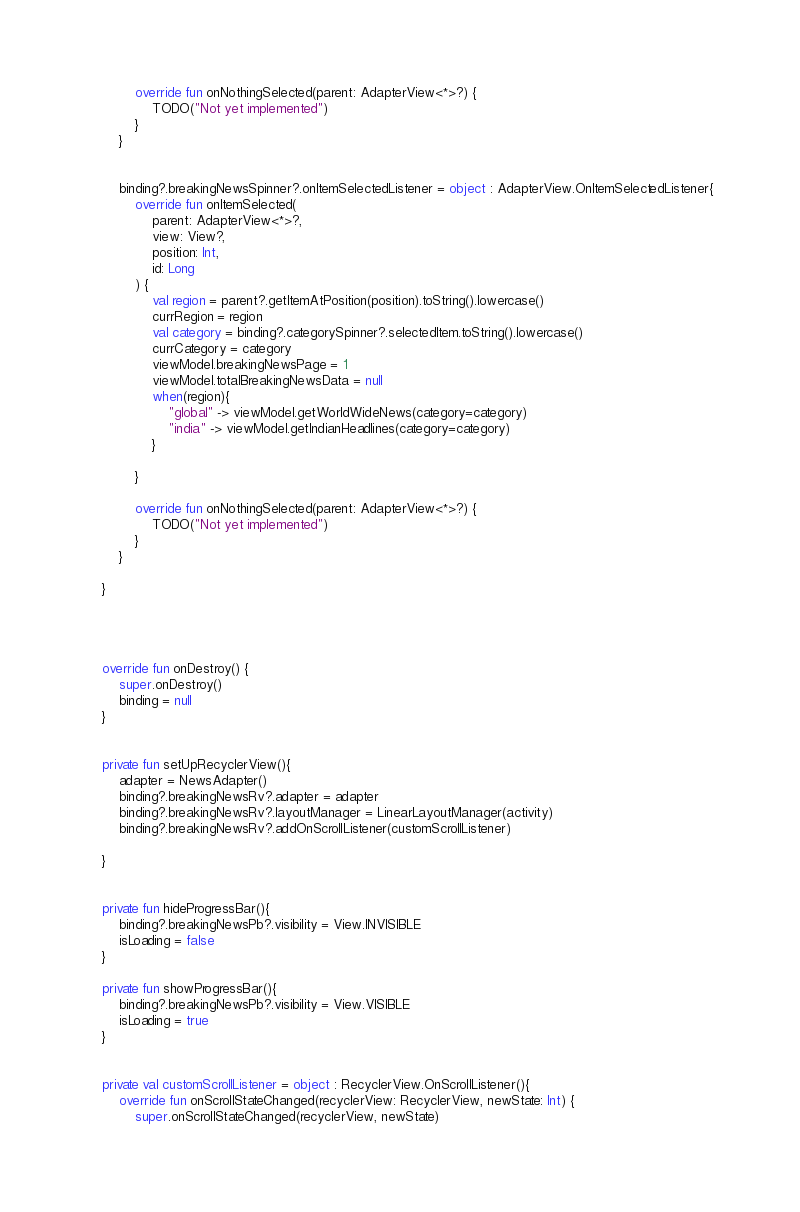Convert code to text. <code><loc_0><loc_0><loc_500><loc_500><_Kotlin_>            override fun onNothingSelected(parent: AdapterView<*>?) {
                TODO("Not yet implemented")
            }
        }


        binding?.breakingNewsSpinner?.onItemSelectedListener = object : AdapterView.OnItemSelectedListener{
            override fun onItemSelected(
                parent: AdapterView<*>?,
                view: View?,
                position: Int,
                id: Long
            ) {
                val region = parent?.getItemAtPosition(position).toString().lowercase()
                currRegion = region
                val category = binding?.categorySpinner?.selectedItem.toString().lowercase()
                currCategory = category
                viewModel.breakingNewsPage = 1
                viewModel.totalBreakingNewsData = null
                when(region){
                    "global" -> viewModel.getWorldWideNews(category=category)
                    "india" -> viewModel.getIndianHeadlines(category=category)
                }

            }

            override fun onNothingSelected(parent: AdapterView<*>?) {
                TODO("Not yet implemented")
            }
        }

    }




    override fun onDestroy() {
        super.onDestroy()
        binding = null
    }


    private fun setUpRecyclerView(){
        adapter = NewsAdapter()
        binding?.breakingNewsRv?.adapter = adapter
        binding?.breakingNewsRv?.layoutManager = LinearLayoutManager(activity)
        binding?.breakingNewsRv?.addOnScrollListener(customScrollListener)

    }


    private fun hideProgressBar(){
        binding?.breakingNewsPb?.visibility = View.INVISIBLE
        isLoading = false
    }

    private fun showProgressBar(){
        binding?.breakingNewsPb?.visibility = View.VISIBLE
        isLoading = true
    }


    private val customScrollListener = object : RecyclerView.OnScrollListener(){
        override fun onScrollStateChanged(recyclerView: RecyclerView, newState: Int) {
            super.onScrollStateChanged(recyclerView, newState)</code> 